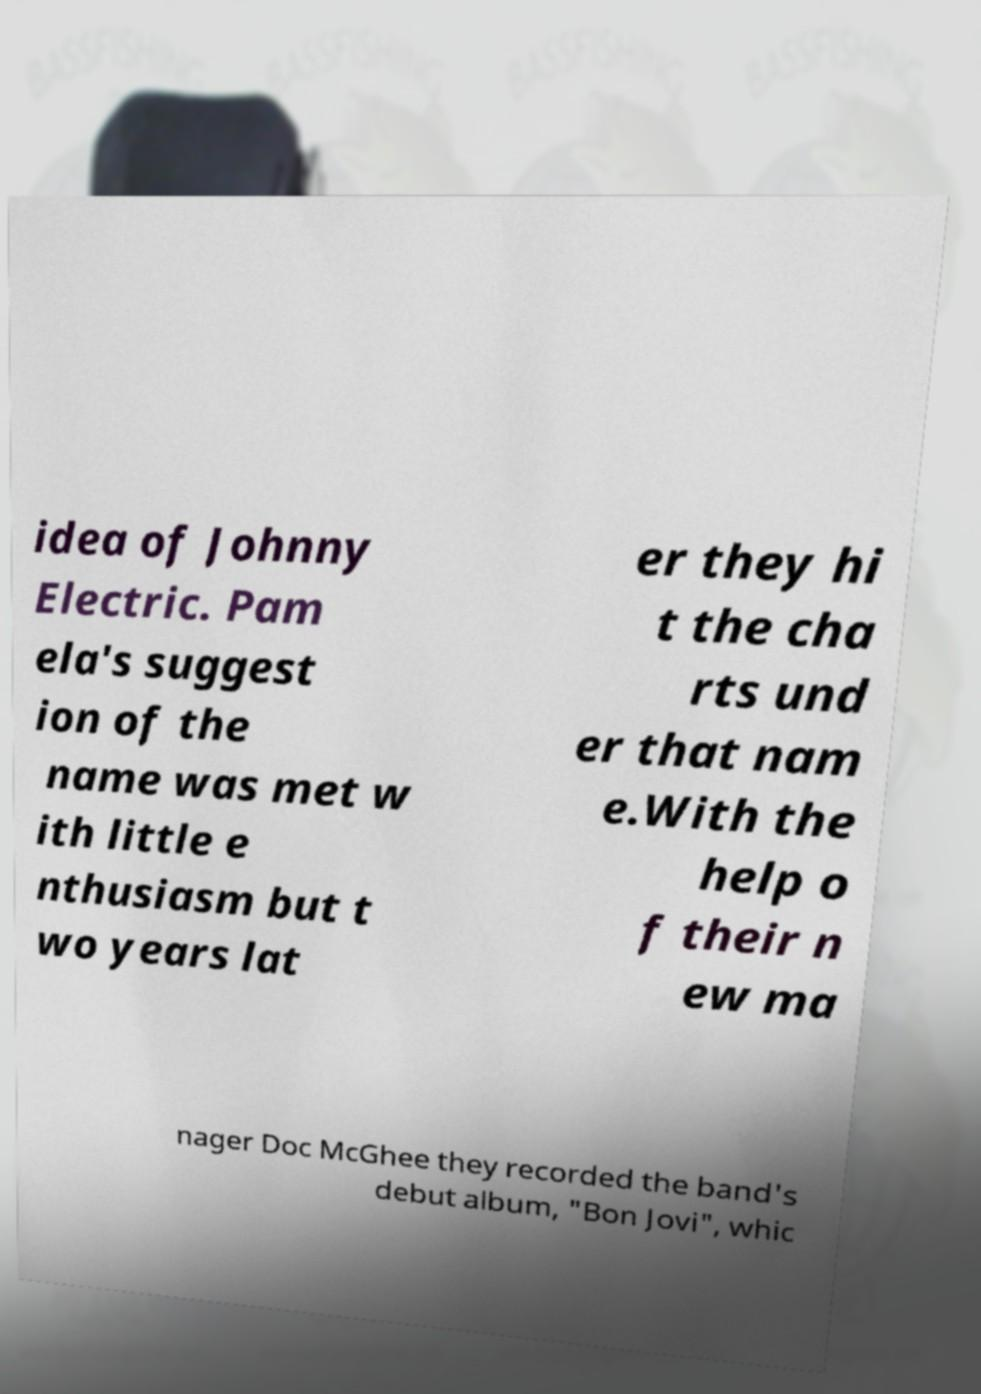Can you read and provide the text displayed in the image?This photo seems to have some interesting text. Can you extract and type it out for me? idea of Johnny Electric. Pam ela's suggest ion of the name was met w ith little e nthusiasm but t wo years lat er they hi t the cha rts und er that nam e.With the help o f their n ew ma nager Doc McGhee they recorded the band's debut album, "Bon Jovi", whic 